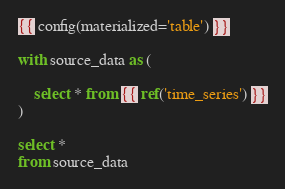Convert code to text. <code><loc_0><loc_0><loc_500><loc_500><_SQL_>{{ config(materialized='table') }}

with source_data as (

    select * from {{ ref('time_series') }}
)

select *
from source_data
</code> 